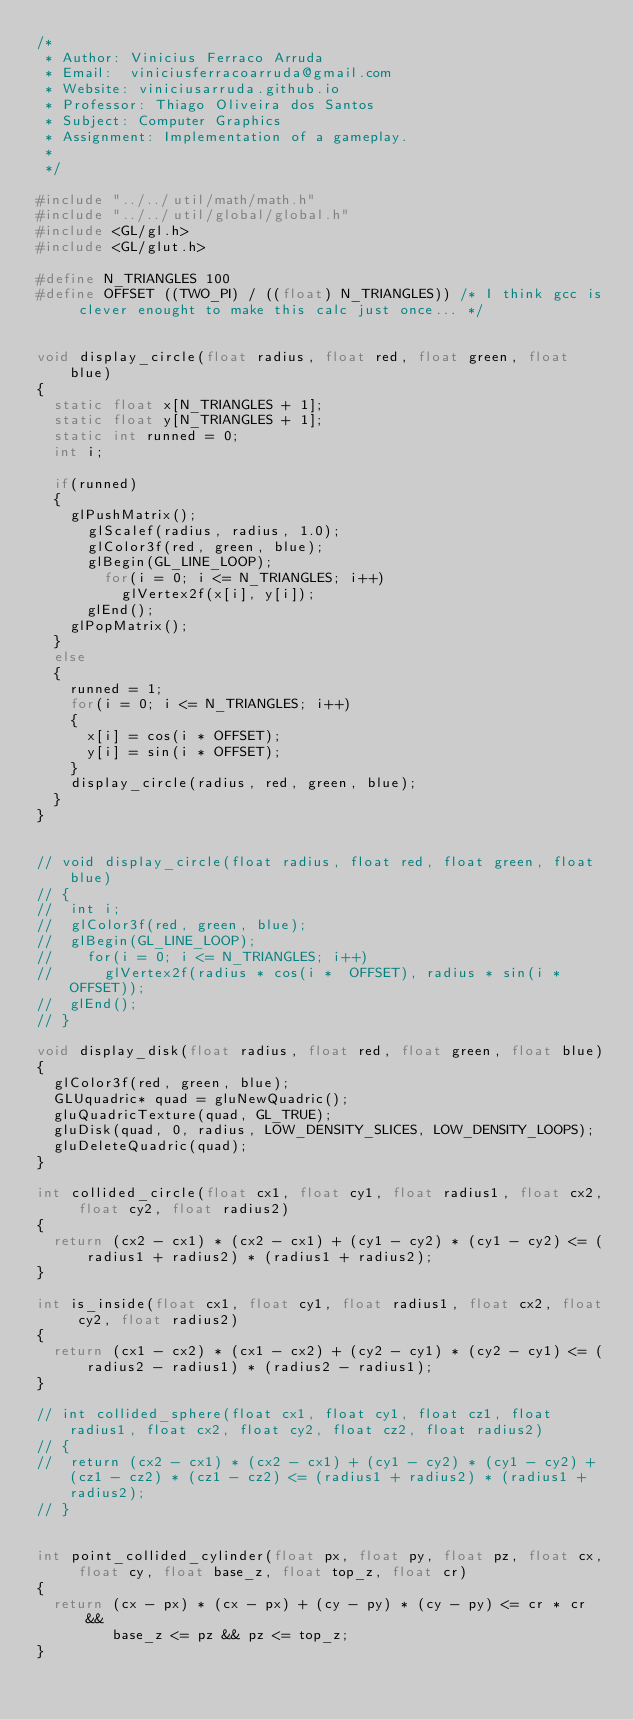Convert code to text. <code><loc_0><loc_0><loc_500><loc_500><_C_>/*
 * Author: Vinicius Ferraco Arruda
 * Email:  viniciusferracoarruda@gmail.com
 * Website: viniciusarruda.github.io
 * Professor: Thiago Oliveira dos Santos
 * Subject: Computer Graphics
 * Assignment: Implementation of a gameplay.
 *
 */
 
#include "../../util/math/math.h"
#include "../../util/global/global.h"
#include <GL/gl.h>
#include <GL/glut.h>

#define N_TRIANGLES 100
#define OFFSET ((TWO_PI) / ((float) N_TRIANGLES)) /* I think gcc is clever enought to make this calc just once... */


void display_circle(float radius, float red, float green, float blue)
{
	static float x[N_TRIANGLES + 1];
	static float y[N_TRIANGLES + 1];
	static int runned = 0;
	int i;

	if(runned)
	{
		glPushMatrix();
			glScalef(radius, radius, 1.0);
			glColor3f(red, green, blue);
			glBegin(GL_LINE_LOOP);
				for(i = 0; i <= N_TRIANGLES; i++) 
					glVertex2f(x[i], y[i]);
			glEnd();
		glPopMatrix();
	}
	else
	{
		runned = 1;
		for(i = 0; i <= N_TRIANGLES; i++) 
		{
			x[i] = cos(i * OFFSET);
			y[i] = sin(i * OFFSET);
		}
		display_circle(radius, red, green, blue);
	}
}


// void display_circle(float radius, float red, float green, float blue)
// {
// 	int i;
// 	glColor3f(red, green, blue);
// 	glBegin(GL_LINE_LOOP);
// 		for(i = 0; i <= N_TRIANGLES; i++) 
// 			glVertex2f(radius * cos(i *  OFFSET), radius * sin(i * OFFSET));
// 	glEnd();
// }

void display_disk(float radius, float red, float green, float blue)
{
	glColor3f(red, green, blue);
	GLUquadric* quad = gluNewQuadric();
	gluQuadricTexture(quad, GL_TRUE);
	gluDisk(quad, 0, radius, LOW_DENSITY_SLICES, LOW_DENSITY_LOOPS);
	gluDeleteQuadric(quad);
}

int collided_circle(float cx1, float cy1, float radius1, float cx2, float cy2, float radius2)
{
	return (cx2 - cx1) * (cx2 - cx1) + (cy1 - cy2) * (cy1 - cy2) <= (radius1 + radius2) * (radius1 + radius2);
}

int is_inside(float cx1, float cy1, float radius1, float cx2, float cy2, float radius2)
{
	return (cx1 - cx2) * (cx1 - cx2) + (cy2 - cy1) * (cy2 - cy1) <= (radius2 - radius1) * (radius2 - radius1);
}

// int collided_sphere(float cx1, float cy1, float cz1, float radius1, float cx2, float cy2, float cz2, float radius2)
// {
// 	return (cx2 - cx1) * (cx2 - cx1) + (cy1 - cy2) * (cy1 - cy2) + (cz1 - cz2) * (cz1 - cz2) <= (radius1 + radius2) * (radius1 + radius2);
// }


int point_collided_cylinder(float px, float py, float pz, float cx, float cy, float base_z, float top_z, float cr)
{
	return (cx - px) * (cx - px) + (cy - py) * (cy - py) <= cr * cr &&
	       base_z <= pz && pz <= top_z; 
}
</code> 